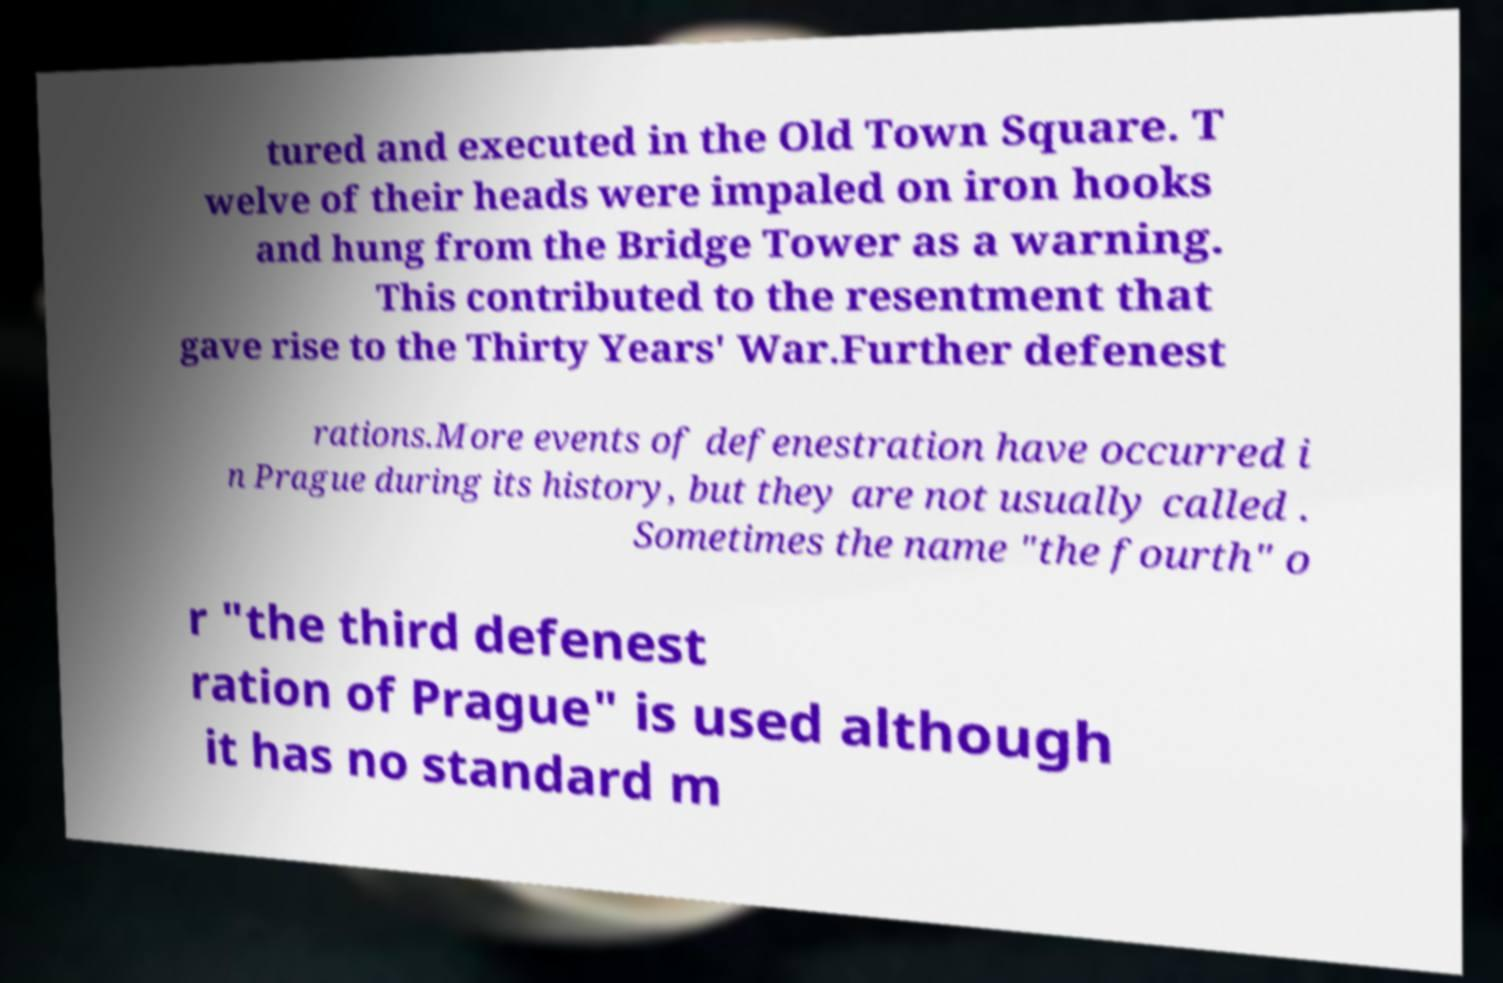What messages or text are displayed in this image? I need them in a readable, typed format. tured and executed in the Old Town Square. T welve of their heads were impaled on iron hooks and hung from the Bridge Tower as a warning. This contributed to the resentment that gave rise to the Thirty Years' War.Further defenest rations.More events of defenestration have occurred i n Prague during its history, but they are not usually called . Sometimes the name "the fourth" o r "the third defenest ration of Prague" is used although it has no standard m 